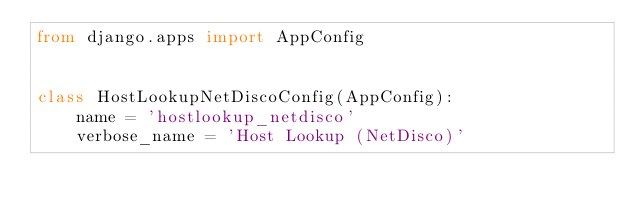Convert code to text. <code><loc_0><loc_0><loc_500><loc_500><_Python_>from django.apps import AppConfig


class HostLookupNetDiscoConfig(AppConfig):
    name = 'hostlookup_netdisco'
    verbose_name = 'Host Lookup (NetDisco)'
</code> 